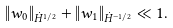<formula> <loc_0><loc_0><loc_500><loc_500>\| w _ { 0 } \| _ { \dot { H } ^ { 1 / 2 } } + \| w _ { 1 } \| _ { \dot { H } ^ { - 1 / 2 } } \ll 1 .</formula> 